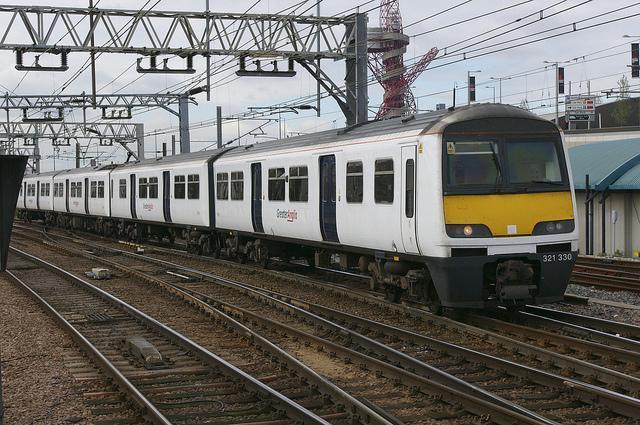How many trains are there?
Give a very brief answer. 1. 